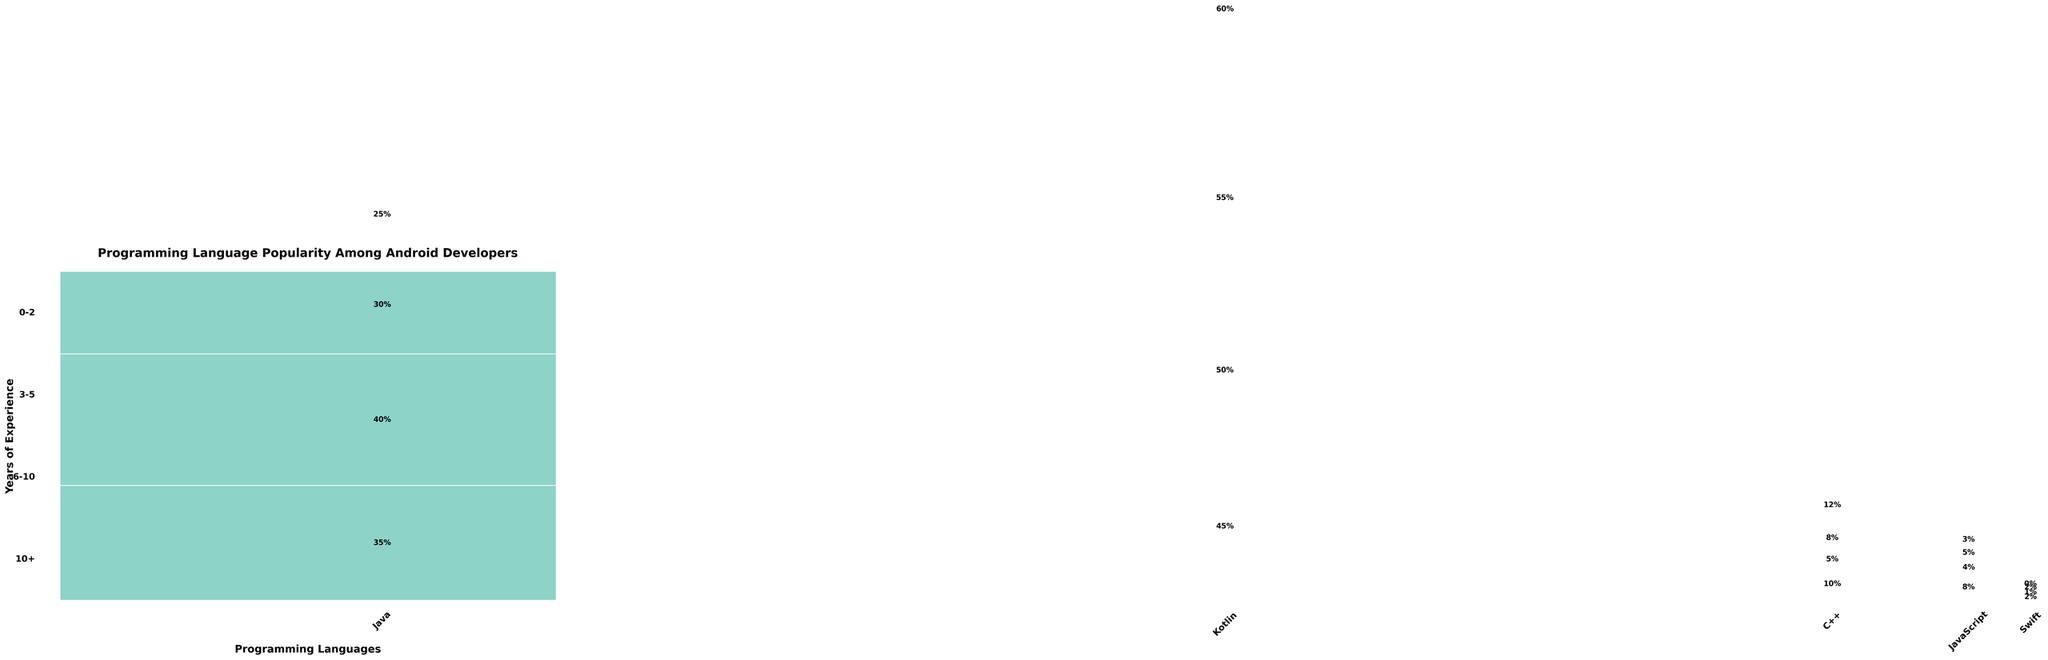Which programming language is represented with the most vibrant color? Observe the shades in the figure, the most vibrant color (bright and noticeable) is typically used for prominent data series.
Answer: Kotlin What percentage of 3-5 years experienced developers use Java? Find the rectangular segment for Java within the 3-5 years experience section and read the percentage value displayed.
Answer: 40% Among developers with 6-10 years of experience, which language has the lowest percentage of use? Compare the heights of the rectangular segments for 6-10 years of experience for all languages and identify the shortest segment.
Answer: Swift What's the total percentage of developers using Kotlin? Sum the percentages of Kotlin across all experience levels: 45% + 50% + 55% + 60%.
Answer: 210% For developers with 10+ years of experience, which two languages are almost equally popular? Compare the neighboring heights of the 10+ years experience segments for all languages and find those closest in height.
Answer: C++ and Java How does the popularity of JavaScript change as developers gain more experience? Observe the JavaScript segments from 0-2 years to 10+ years and note the trend of decreasing height.
Answer: Decreases What's the combined percentage of developers with 0-2 years of experience using Java or Kotlin? Sum the percentage values for Java and Kotlin for 0-2 years: 35% + 45%.
Answer: 80% Which language shows a consistent increase in usage with experience? Review the segments for each language across the experience spectrum and identify the one with a rising trend.
Answer: Kotlin Do any languages have a percentage of 0 with higher experience levels? Check all segments for higher experience levels (10+) and identify any languages with a segment height of zero.
Answer: Swift 